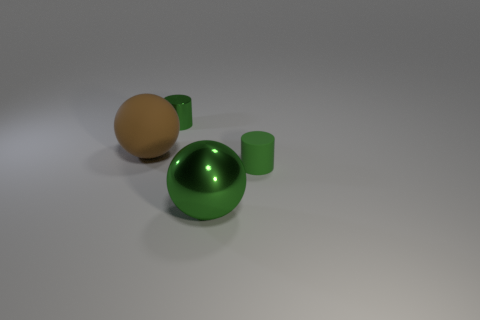Add 4 green metallic cylinders. How many objects exist? 8 Subtract all small things. Subtract all small matte cylinders. How many objects are left? 1 Add 3 shiny cylinders. How many shiny cylinders are left? 4 Add 3 large yellow cylinders. How many large yellow cylinders exist? 3 Subtract 0 brown cubes. How many objects are left? 4 